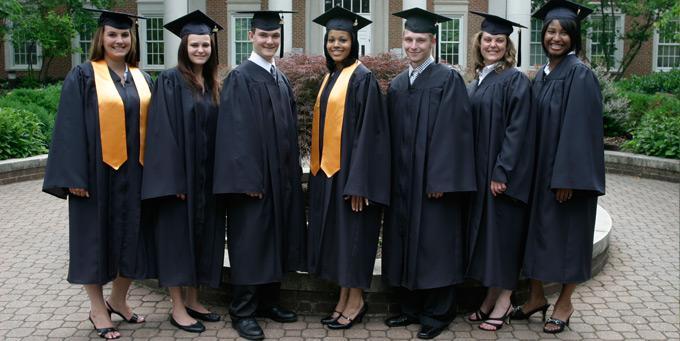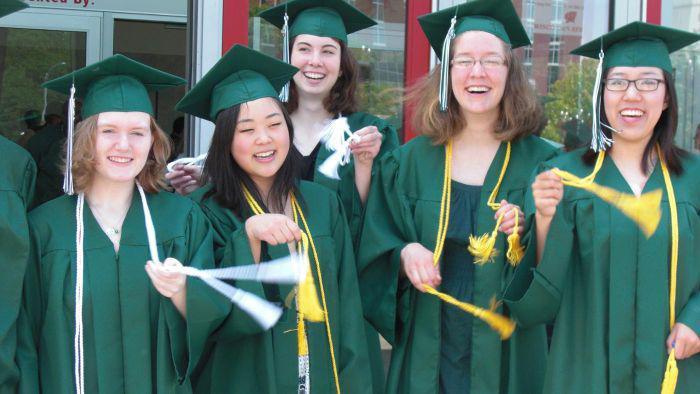The first image is the image on the left, the second image is the image on the right. Analyze the images presented: Is the assertion "One image shows a row of all front-facing graduates in black robes, and none wear colored sashes." valid? Answer yes or no. No. The first image is the image on the left, the second image is the image on the right. Analyze the images presented: Is the assertion "Three people are posing together in graduation attire in one of the images." valid? Answer yes or no. No. 